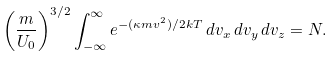<formula> <loc_0><loc_0><loc_500><loc_500>\left ( \frac { m } { U _ { 0 } } \right ) ^ { 3 / 2 } \int ^ { \infty } _ { - \infty } e ^ { - ( \kappa m v ^ { 2 } ) / 2 k T } \, d v _ { x } \, d v _ { y } \, d v _ { z } = N .</formula> 